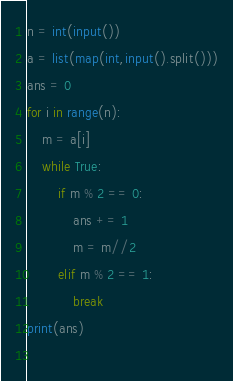Convert code to text. <code><loc_0><loc_0><loc_500><loc_500><_Python_>n = int(input())
a = list(map(int,input().split()))
ans = 0
for i in range(n):
    m = a[i]
    while True:
        if m % 2 == 0:
            ans += 1
            m = m//2
        elif m % 2 == 1:
            break
print(ans)
             </code> 